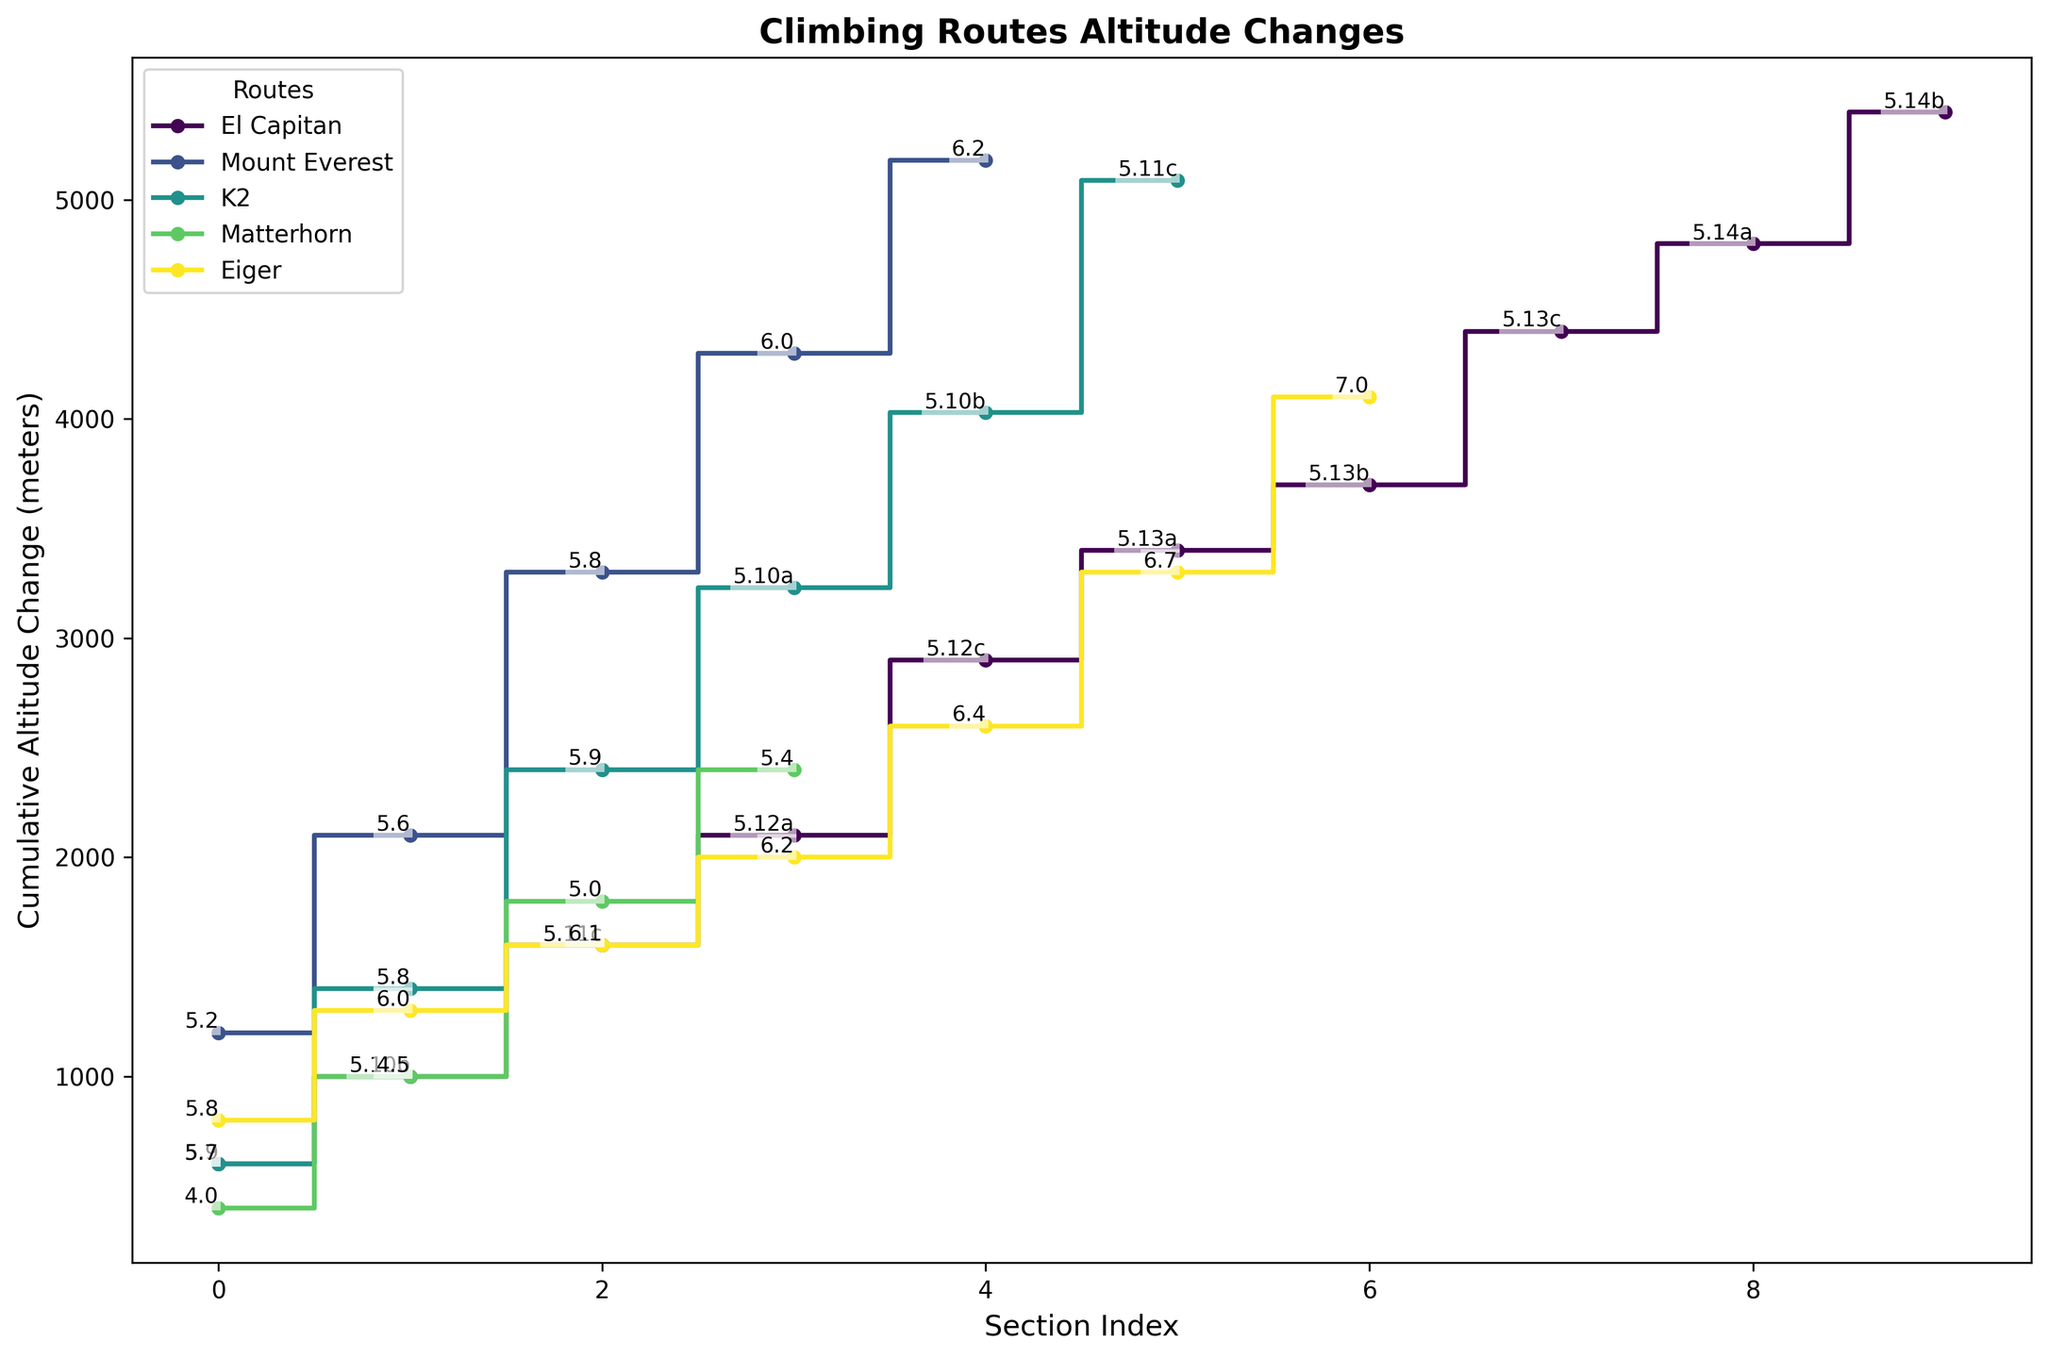What is the highest cumulative altitude change for the route El Capitan? The figure shows the cumulative altitude changes represented by step plots. By looking at the end of the El Capitan's line, we observe the highest point.
Answer: 5400 meters Which section on Mount Everest has the highest altitude change? By observing the length of the steps along Mount Everest’s line, the tallest step represents the highest altitude change. The step from Base Camp to Camp I stands out.
Answer: Base Camp to Camp I Compare the initial altitude changes for El Capitan and Mount Everest. Which is greater? By comparing the first step increment of each route, the rate of altitude change for Mount Everest from Base Camp to Camp I is steeper and taller than El Capitan's initial change to Sickle Ledge.
Answer: Mount Everest Which route has the steepest last ascent section before the summit? Examine the height of the last step for each route before reaching the summit, noting that Eiger's Icefield to Summit section appears highest.
Answer: Eiger What is the average altitude change per section for K2? Adding the altitude changes for K2 (600 + 800 + 1000 + 830 + 800 + 1060) and dividing by the number of sections (6), the average is calculated.
Answer: 848.33 meters How does the altitude change from Camp IV to the Summit on El Capitan compare with that of Camp IV to the Summit on Mount Everest? By directly comparing the height of the final steps for both routes, you see that El Capitan's change of 600 meters is smaller than Mount Everest's 880 meters.
Answer: Less on El Capitan Which section has the highest difficulty level on El Capitan and what is its altitude change? By identifying the highest difficulty rating along El Capitan's line, the Changing Corners to Summit section rates at 5.14b with an altitude change of 600 meters.
Answer: Changing Corners to Summit, 600 meters What proportion of El Capitan's total altitude change occurs in sections rated above 5.13? Summing the altitude changes for sections above 5.13 (Great Roof to Pancake Flake, Pancake Flake to Camp VI, Camp VI to Changing Corners, Changing Corners to Summit) and dividing by the total altitude (5400), and multiplying by 100 for percentage.
Answer: 37.04% Which route has the smallest cumulative altitude change to its summit? By observing the total height climbed along each line, Matterhorn reaches the summit with the smallest cumulative total.
Answer: Matterhorn 